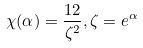<formula> <loc_0><loc_0><loc_500><loc_500>\chi ( \alpha ) = { \frac { 1 2 } { \zeta ^ { 2 } } } , \zeta = e ^ { \alpha }</formula> 